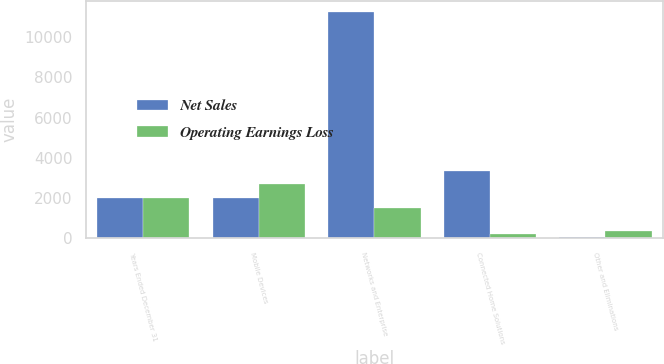<chart> <loc_0><loc_0><loc_500><loc_500><stacked_bar_chart><ecel><fcel>Years Ended December 31<fcel>Mobile Devices<fcel>Networks and Enterprise<fcel>Connected Home Solutions<fcel>Other and Eliminations<nl><fcel>Net Sales<fcel>2006<fcel>2006<fcel>11245<fcel>3327<fcel>76<nl><fcel>Operating Earnings Loss<fcel>2006<fcel>2690<fcel>1521<fcel>224<fcel>343<nl></chart> 